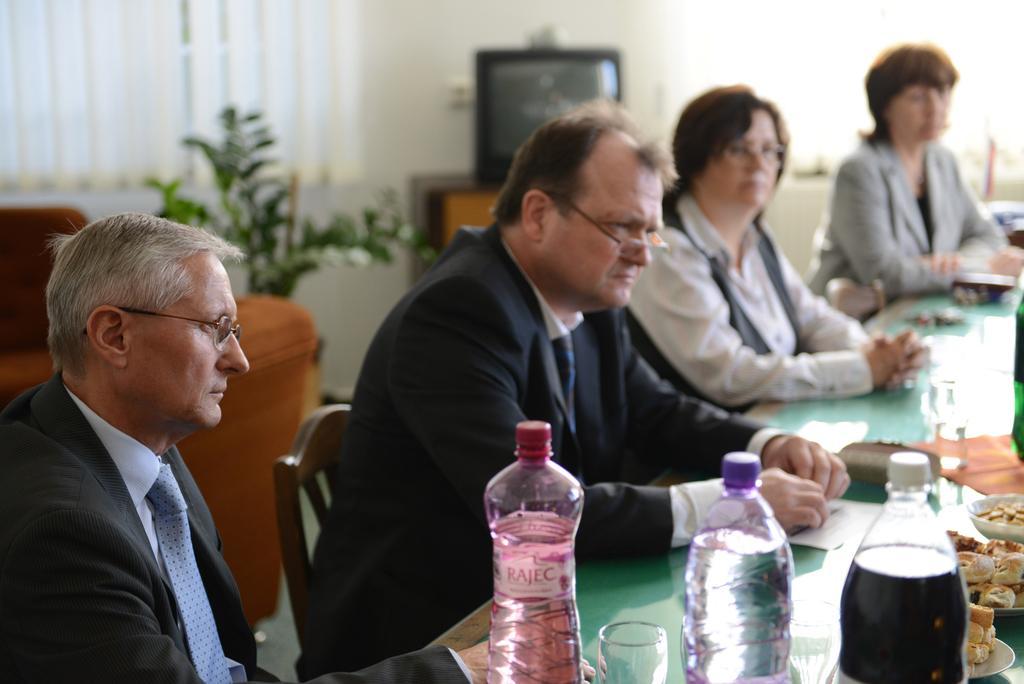How would you summarize this image in a sentence or two? This picture describes about group of people they are all seated on the chair, in front of them we can find couple of bottles, glasses, plates and some food on the table, in the background we can see a plant and television. 